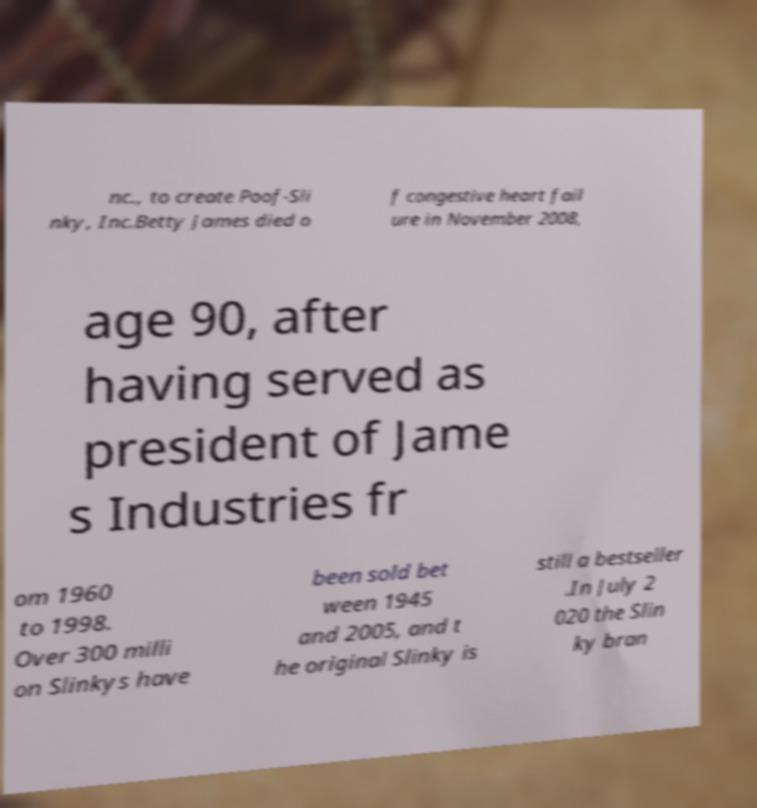Please identify and transcribe the text found in this image. nc., to create Poof-Sli nky, Inc.Betty James died o f congestive heart fail ure in November 2008, age 90, after having served as president of Jame s Industries fr om 1960 to 1998. Over 300 milli on Slinkys have been sold bet ween 1945 and 2005, and t he original Slinky is still a bestseller .In July 2 020 the Slin ky bran 